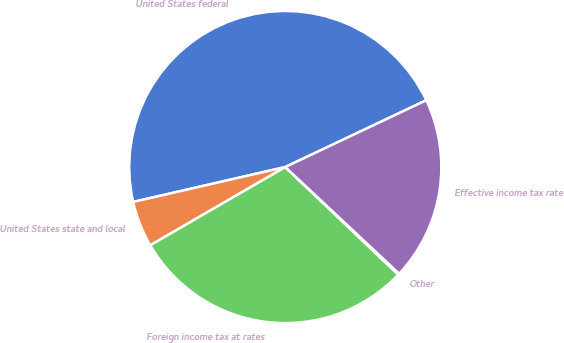Convert chart. <chart><loc_0><loc_0><loc_500><loc_500><pie_chart><fcel>United States federal<fcel>United States state and local<fcel>Foreign income tax at rates<fcel>Other<fcel>Effective income tax rate<nl><fcel>46.55%<fcel>4.77%<fcel>29.53%<fcel>0.13%<fcel>19.02%<nl></chart> 